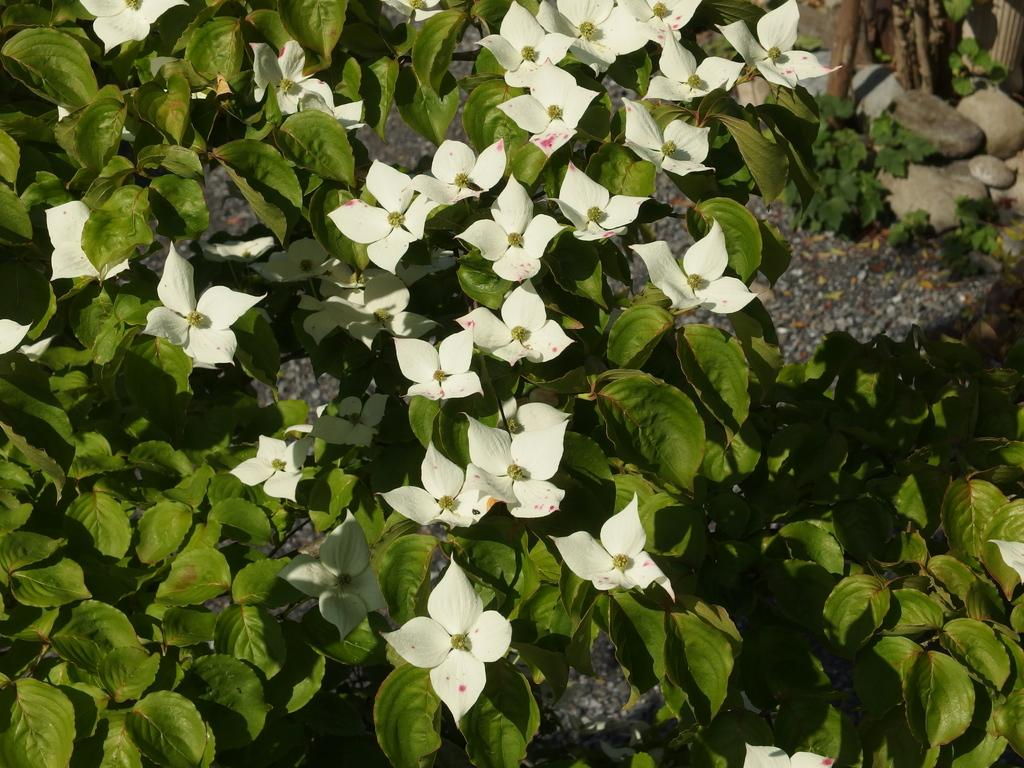What type of living organisms can be seen in the image? Plants can be seen in the image. What color are the flowers on the plants? The flowers on the plants are white. What color are the leaves on the plants? The leaves on the plants are green. What can be seen on the ground in the background of the image? Stones can be seen on the ground in the background of the image. What type of behavior can be observed in the glass in the image? There is no glass present in the image, so no behavior can be observed in it. 